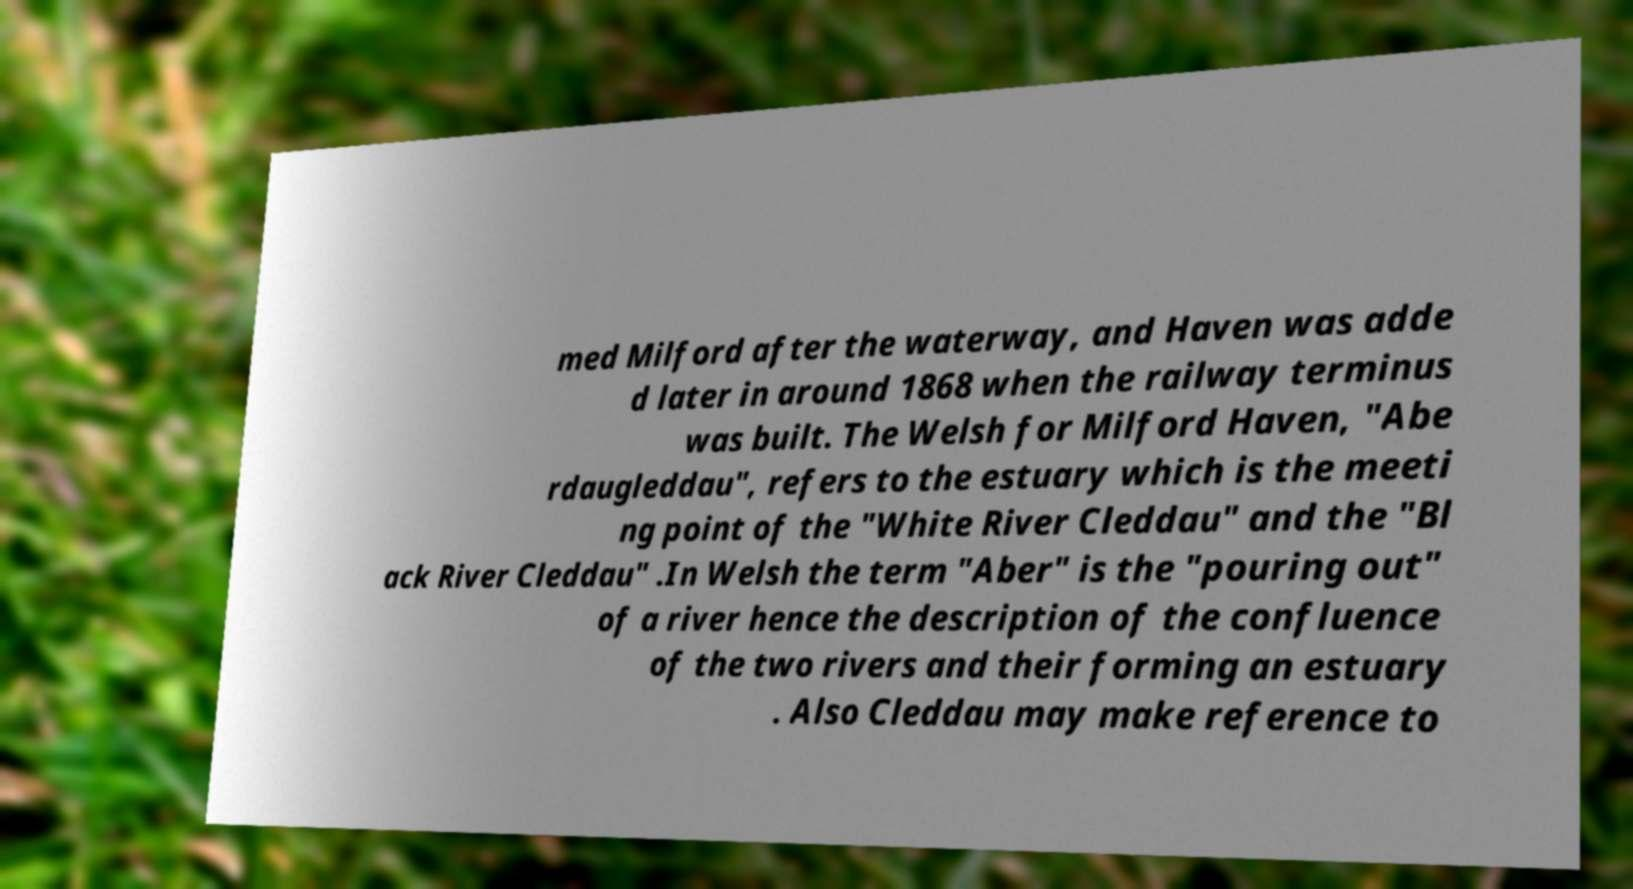Please read and relay the text visible in this image. What does it say? med Milford after the waterway, and Haven was adde d later in around 1868 when the railway terminus was built. The Welsh for Milford Haven, "Abe rdaugleddau", refers to the estuary which is the meeti ng point of the "White River Cleddau" and the "Bl ack River Cleddau" .In Welsh the term "Aber" is the "pouring out" of a river hence the description of the confluence of the two rivers and their forming an estuary . Also Cleddau may make reference to 